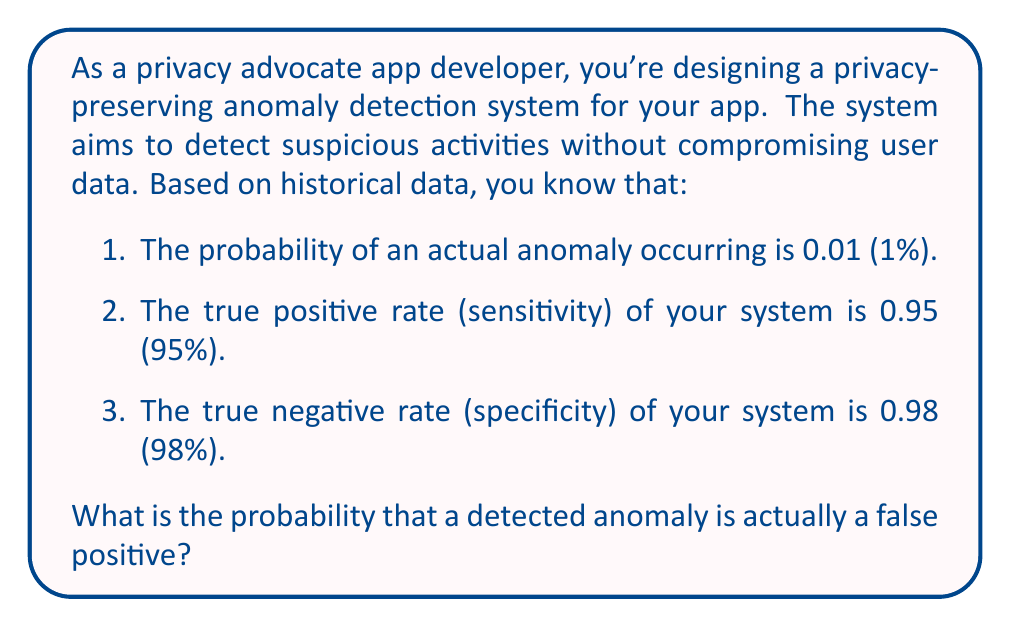Teach me how to tackle this problem. To solve this problem, we'll use Bayes' theorem. Let's define our events:

A: Actual anomaly
D: Detected anomaly

We want to find P(not A | D), which is the probability of no actual anomaly given a detected anomaly (false positive rate).

Given:
P(A) = 0.01 (probability of actual anomaly)
P(D|A) = 0.95 (true positive rate)
P(not D|not A) = 0.98 (true negative rate)

Step 1: Calculate P(not A) = 1 - P(A) = 1 - 0.01 = 0.99

Step 2: Calculate P(D|not A) = 1 - P(not D|not A) = 1 - 0.98 = 0.02

Step 3: Use Bayes' theorem to calculate P(not A | D):

$$ P(\text{not A} | D) = \frac{P(D|\text{not A}) \cdot P(\text{not A})}{P(D|\text{not A}) \cdot P(\text{not A}) + P(D|A) \cdot P(A)} $$

Step 4: Substitute the values:

$$ P(\text{not A} | D) = \frac{0.02 \cdot 0.99}{0.02 \cdot 0.99 + 0.95 \cdot 0.01} $$

Step 5: Calculate the numerator and denominator:

$$ P(\text{not A} | D) = \frac{0.0198}{0.0198 + 0.0095} = \frac{0.0198}{0.0293} $$

Step 6: Perform the division:

$$ P(\text{not A} | D) \approx 0.6758 $$

Therefore, the probability that a detected anomaly is actually a false positive is approximately 0.6758 or 67.58%.
Answer: 0.6758 or 67.58% 